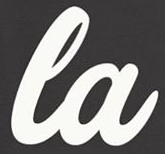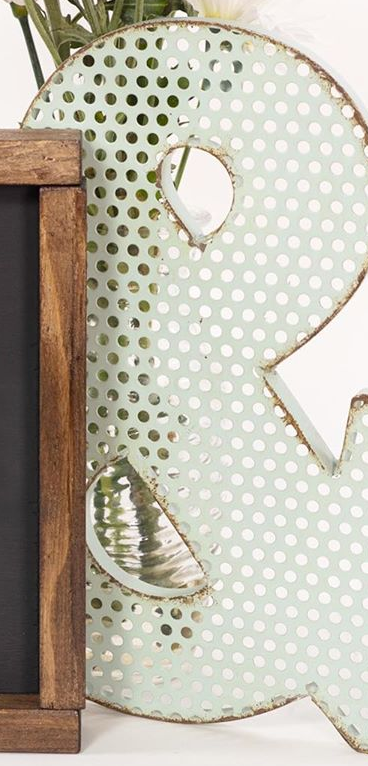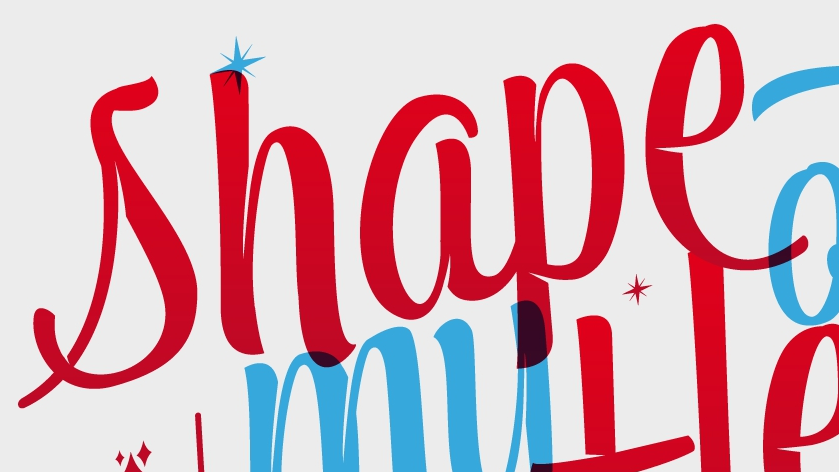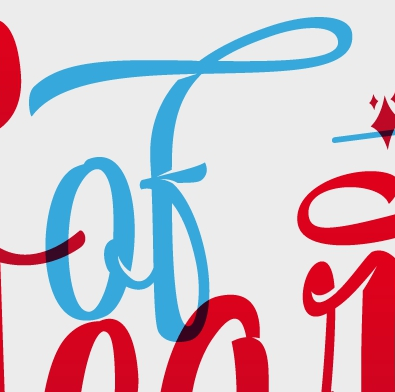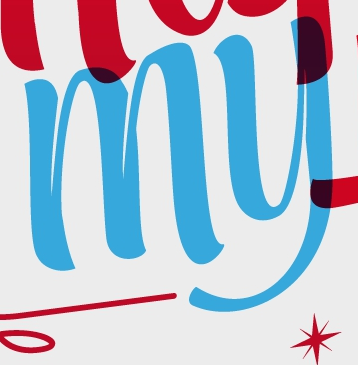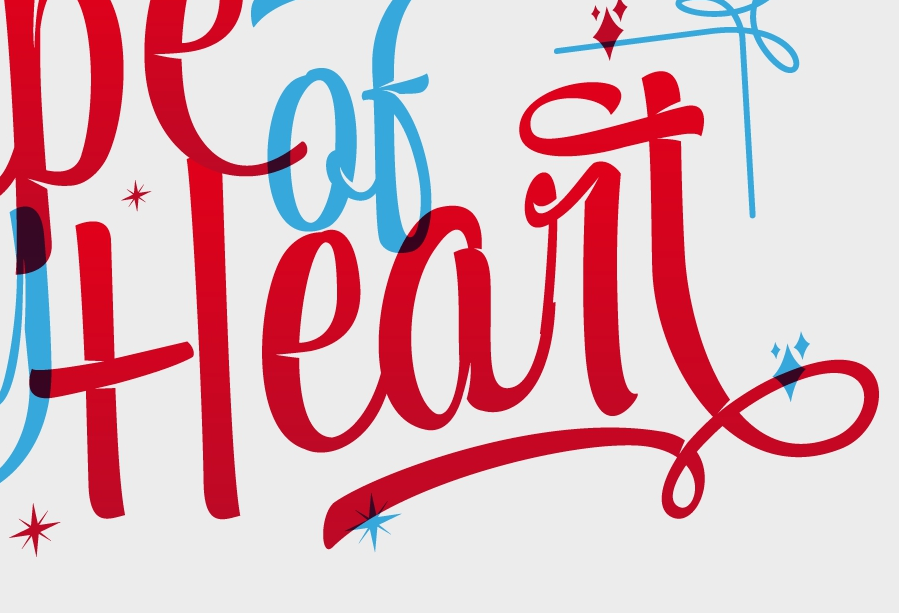What text appears in these images from left to right, separated by a semicolon? la; &; shape; of; my; Heart 